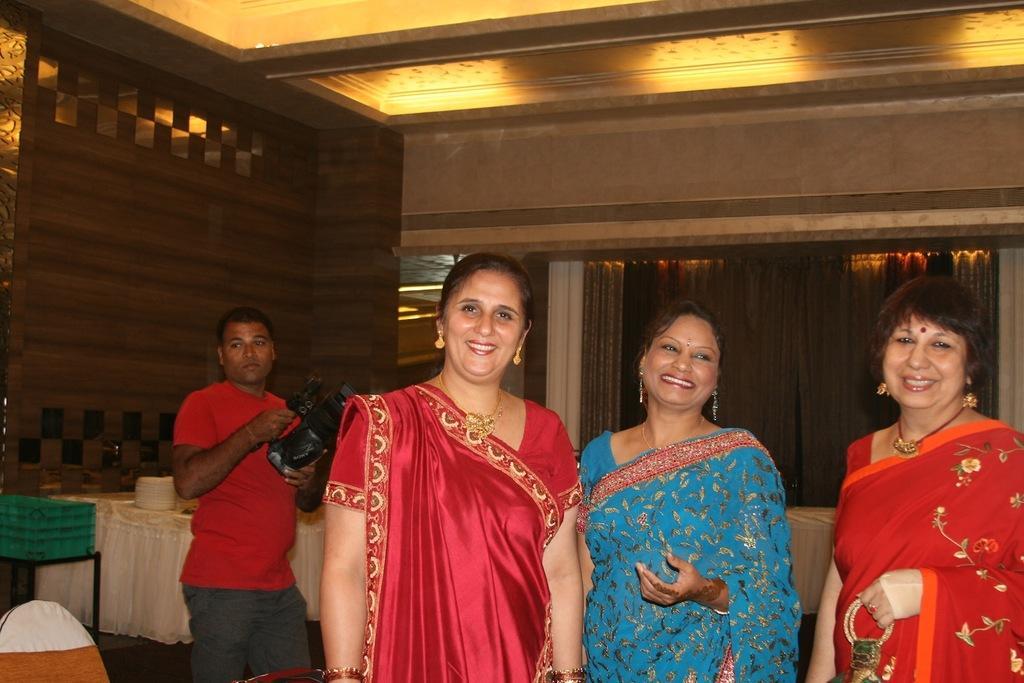Describe this image in one or two sentences. In the center of the image we can see three persons are standing and they are smiling and they are in different costumes. Among them, we can see one person is holding some object. In the background there is a wall, table, cloth, lights, curtains, one person is standing and holding some object and a few other objects. 